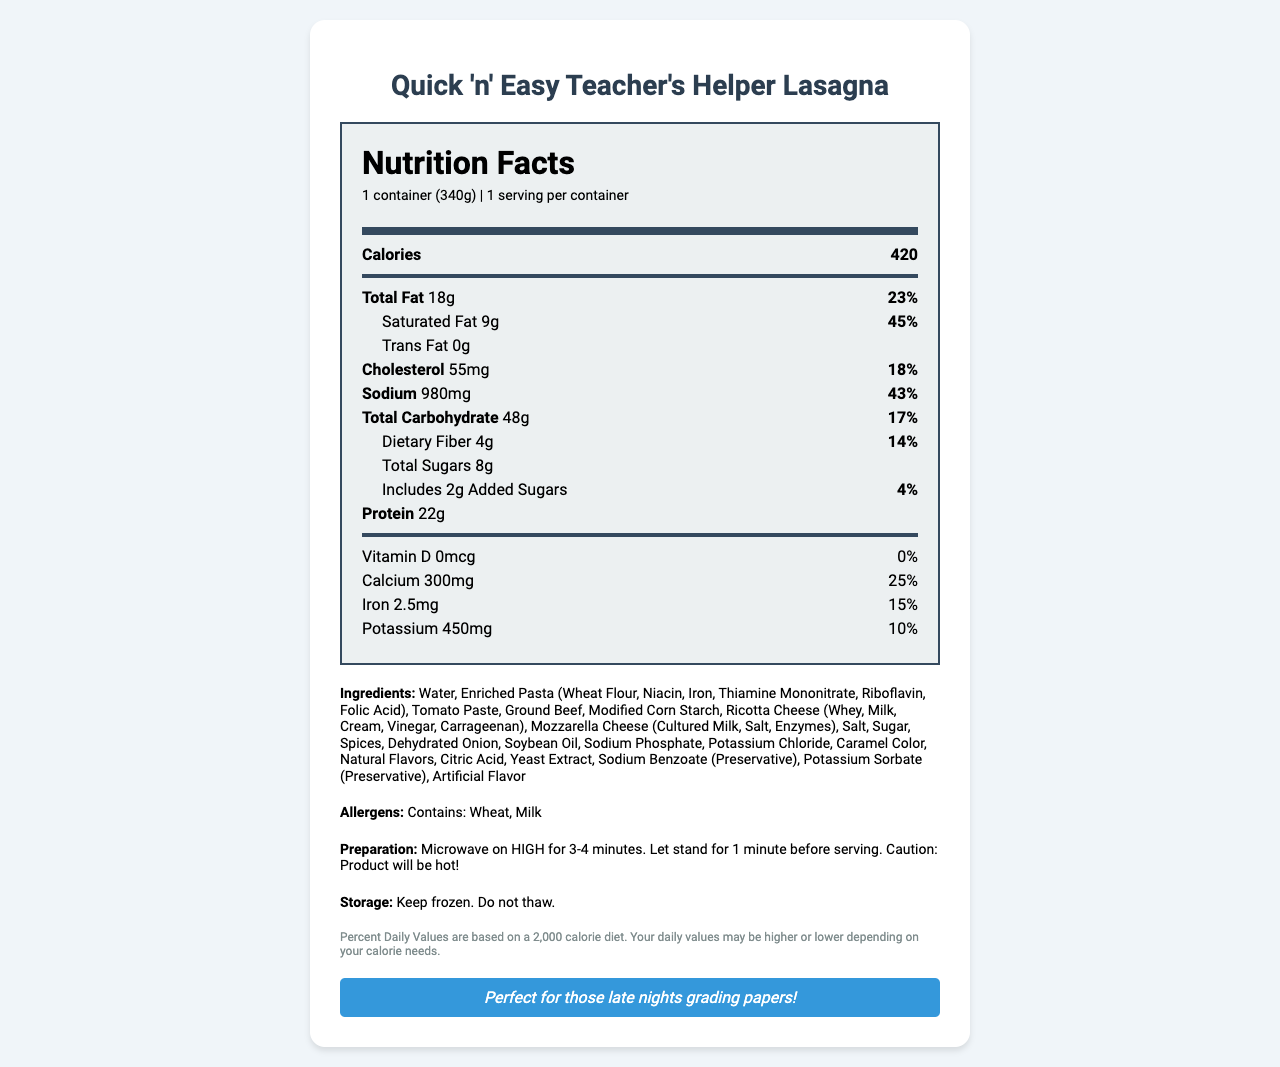what is the serving size? The serving size is listed near the top of the document.
Answer: 1 container (340g) how many calories are in one serving? The calories per serving are displayed prominently in the nutrition facts section.
Answer: 420 how much total fat does the lasagna contain? The amount of total fat is indicated in the nutrition facts section.
Answer: 18g what is the daily value percentage for sodium? The daily value percentage for sodium is provided in the nutrition facts section.
Answer: 43% how many grams of protein are in the lasagna? The protein content in grams is available in the nutrition facts section.
Answer: 22g what is the cooking time in the microwave? The preparation instructions show the cooking time in the microwave.
Answer: 3-4 minutes how should the lasagna be stored? The storage instructions recommend keeping the product frozen and not thawing it.
Answer: Keep frozen. Do not thaw. what is the total carbohydrate content and its daily value percentage? The nutrition facts section lists the total carbohydrate content and its corresponding daily value percentage.
Answer: 48g, 17% which company manufactures the lasagna? The manufacturer's name is located at the bottom of the document.
Answer: FastMeal Solutions, Inc. how much cholesterol does the lasagna have? A. 30mg B. 45mg C. 55mg The amount of cholesterol is given in the nutrition facts section as 55mg.
Answer: C how many grams of dietary fiber does the lasagna contain? A. 4g B. 6g C. 8g D. 10g The dietary fiber content listed in the nutrition facts is 4g.
Answer: A does the product contain any allergens? The document states that the lasagna contains wheat and milk.
Answer: Yes do the nutrition facts indicate any vitamin D content? The vitamin D content is listed as 0 mcg, with 0% daily value indicated.
Answer: No list all the preservatives mentioned in the ingredients. The preservatives, Sodium Benzoate and Potassium Sorbate, are listed in the ingredients section.
Answer: Sodium Benzoate, Potassium Sorbate does the lasagna contain any artificial flavors? The ingredients section confirms the presence of artificial flavor.
Answer: Yes summarize the main idea of the document. The document includes nutrition facts, ingredients, allergens, preparation instructions, and manufacturer details, highlighting key attributes like high sodium and preservative content.
Answer: The document provides detailed information about the nutritional content, ingredients, and other relevant details of Quick 'n' Easy Teacher's Helper Lasagna, a microwaveable dinner option ideal for busy teachers. can this document confirm the product's taste quality? The document only provides nutritional and preparatory details but does not give any information regarding the taste quality of the lasagna.
Answer: Not enough information 